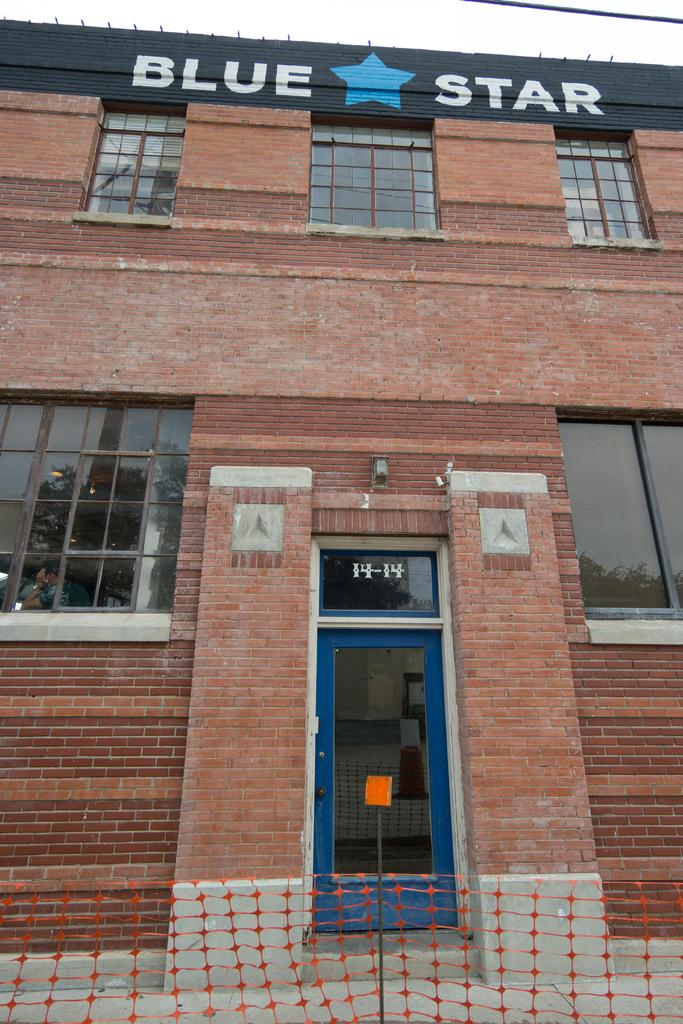What type of structure is present in the image? There is a building in the image. What features can be observed on the building? The building has windows and a door. What is in front of the building? There is a net and a pole in front of the building. What can be seen in the background of the image? The sky is visible in the background of the image. Can you tell me how many balls are rolling down the stream in the image? There is no stream or balls present in the image; it features a building with a net and pole in front of it. 